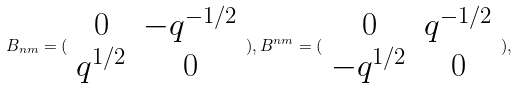Convert formula to latex. <formula><loc_0><loc_0><loc_500><loc_500>B _ { n m } = ( \begin{array} { c c } 0 & - q ^ { - 1 / 2 } \\ q ^ { 1 / 2 } & 0 \end{array} ) , B ^ { n m } = ( \begin{array} { c c } 0 & q ^ { - 1 / 2 } \\ - q ^ { 1 / 2 } & 0 \end{array} ) ,</formula> 